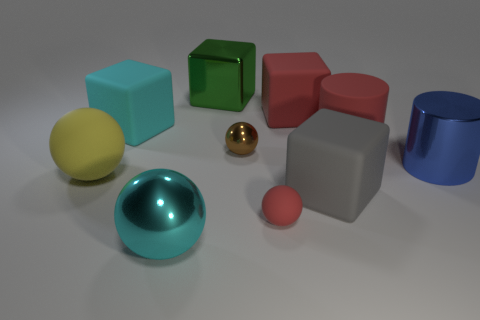Subtract 1 spheres. How many spheres are left? 3 Subtract all blue balls. Subtract all yellow cylinders. How many balls are left? 4 Subtract all cylinders. How many objects are left? 8 Add 1 brown metallic balls. How many brown metallic balls are left? 2 Add 1 big red cylinders. How many big red cylinders exist? 2 Subtract 0 purple spheres. How many objects are left? 10 Subtract all brown metallic things. Subtract all red cylinders. How many objects are left? 8 